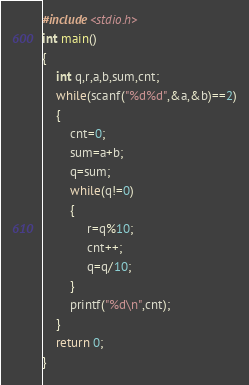<code> <loc_0><loc_0><loc_500><loc_500><_C_>#include<stdio.h>
int main()
{
    int q,r,a,b,sum,cnt;
    while(scanf("%d%d",&a,&b)==2)
    {
        cnt=0;
        sum=a+b;
        q=sum;
        while(q!=0)
        {
             r=q%10;
             cnt++;
             q=q/10;
        }
        printf("%d\n",cnt);
    }
    return 0;
}
</code> 